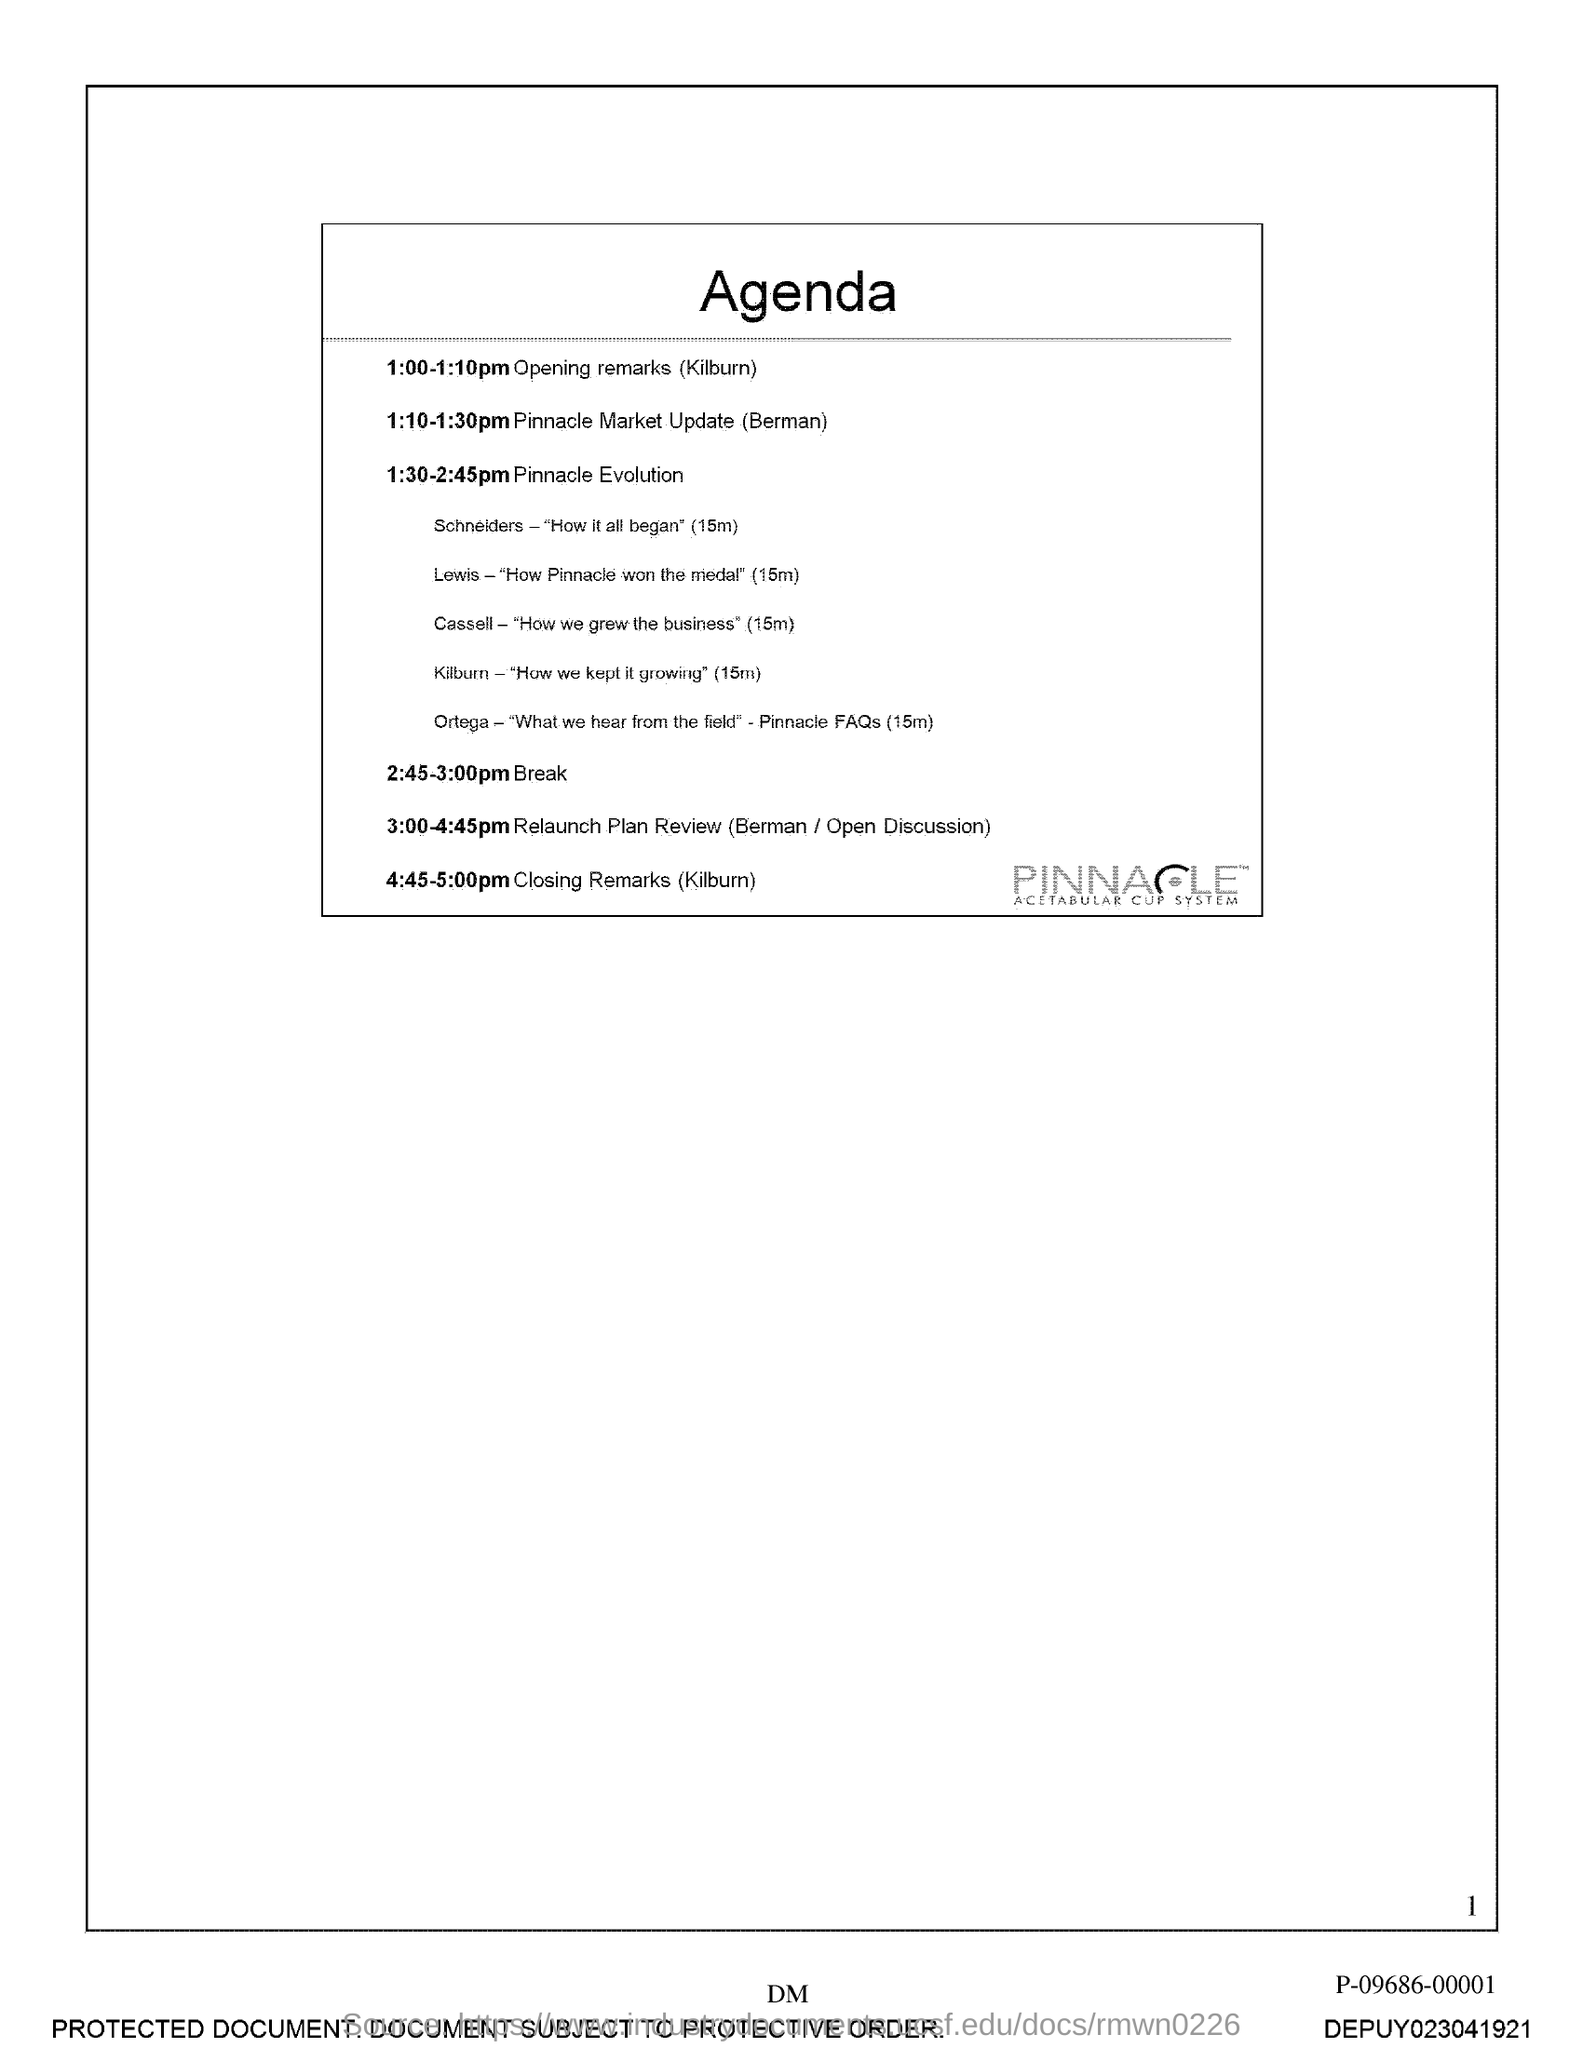Point out several critical features in this image. The title of the document is 'agenda.' The page number is 1, and I will provide a numerical list of each page from 1 to... 